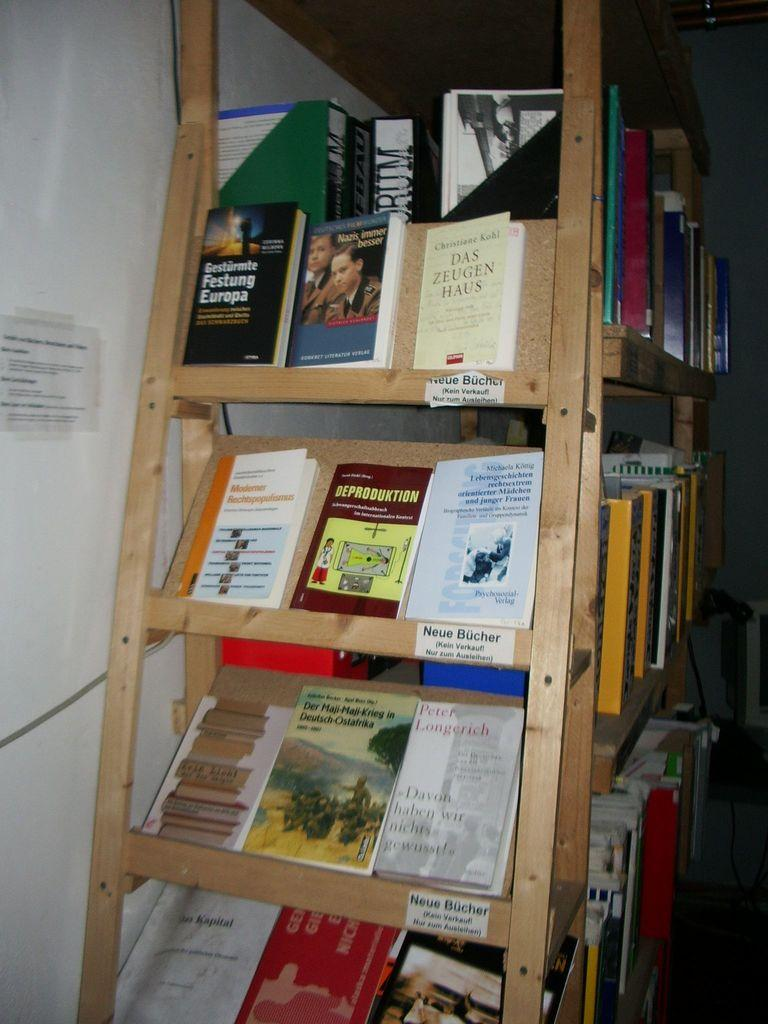<image>
Summarize the visual content of the image. A shelf with books on it the middle shelf is labeled Neue Bucher. 